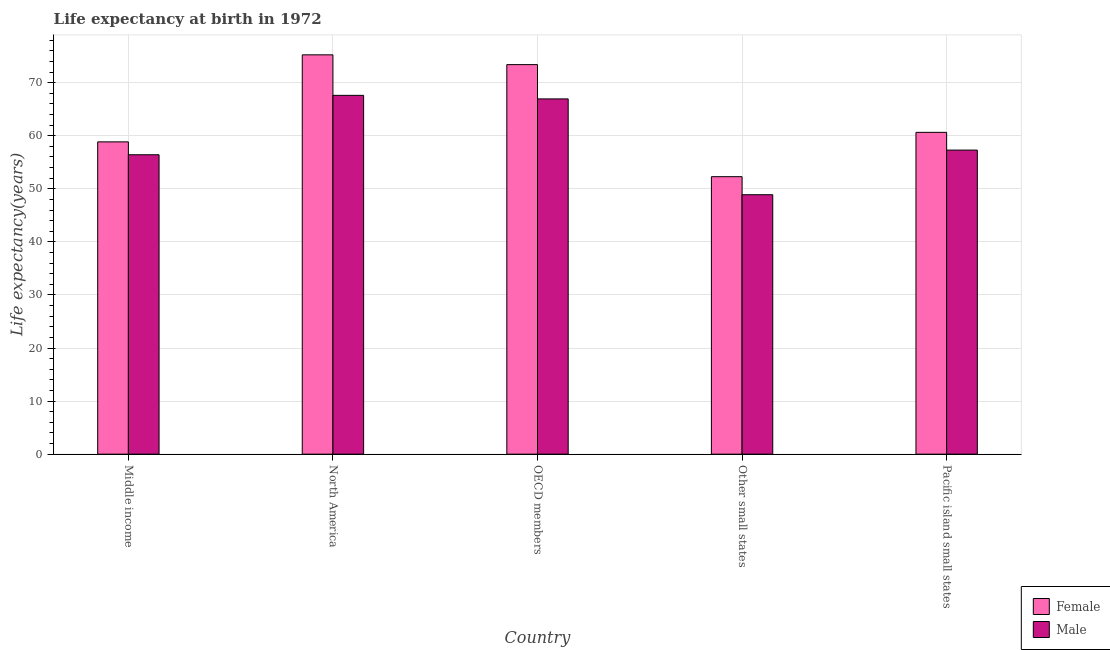How many groups of bars are there?
Keep it short and to the point. 5. Are the number of bars on each tick of the X-axis equal?
Ensure brevity in your answer.  Yes. How many bars are there on the 3rd tick from the left?
Give a very brief answer. 2. How many bars are there on the 5th tick from the right?
Your answer should be very brief. 2. What is the label of the 4th group of bars from the left?
Provide a succinct answer. Other small states. What is the life expectancy(male) in Middle income?
Your response must be concise. 56.41. Across all countries, what is the maximum life expectancy(male)?
Your response must be concise. 67.6. Across all countries, what is the minimum life expectancy(female)?
Your response must be concise. 52.28. In which country was the life expectancy(female) maximum?
Give a very brief answer. North America. In which country was the life expectancy(female) minimum?
Give a very brief answer. Other small states. What is the total life expectancy(female) in the graph?
Your answer should be compact. 320.38. What is the difference between the life expectancy(male) in North America and that in OECD members?
Ensure brevity in your answer.  0.67. What is the difference between the life expectancy(female) in Pacific island small states and the life expectancy(male) in Other small states?
Offer a terse response. 11.75. What is the average life expectancy(male) per country?
Your answer should be very brief. 59.42. What is the difference between the life expectancy(male) and life expectancy(female) in Middle income?
Provide a short and direct response. -2.43. In how many countries, is the life expectancy(female) greater than 4 years?
Offer a terse response. 5. What is the ratio of the life expectancy(female) in North America to that in Other small states?
Offer a terse response. 1.44. Is the difference between the life expectancy(male) in Middle income and North America greater than the difference between the life expectancy(female) in Middle income and North America?
Provide a short and direct response. Yes. What is the difference between the highest and the second highest life expectancy(male)?
Your answer should be compact. 0.67. What is the difference between the highest and the lowest life expectancy(male)?
Offer a terse response. 18.72. Is the sum of the life expectancy(male) in Middle income and North America greater than the maximum life expectancy(female) across all countries?
Offer a terse response. Yes. What does the 1st bar from the left in Middle income represents?
Offer a terse response. Female. What does the 1st bar from the right in Other small states represents?
Your answer should be compact. Male. How many bars are there?
Offer a very short reply. 10. Are all the bars in the graph horizontal?
Your answer should be compact. No. How many countries are there in the graph?
Provide a succinct answer. 5. Are the values on the major ticks of Y-axis written in scientific E-notation?
Provide a succinct answer. No. Does the graph contain grids?
Your answer should be compact. Yes. Where does the legend appear in the graph?
Give a very brief answer. Bottom right. What is the title of the graph?
Provide a short and direct response. Life expectancy at birth in 1972. What is the label or title of the X-axis?
Your answer should be very brief. Country. What is the label or title of the Y-axis?
Offer a very short reply. Life expectancy(years). What is the Life expectancy(years) of Female in Middle income?
Keep it short and to the point. 58.84. What is the Life expectancy(years) in Male in Middle income?
Ensure brevity in your answer.  56.41. What is the Life expectancy(years) in Female in North America?
Your answer should be very brief. 75.24. What is the Life expectancy(years) in Male in North America?
Ensure brevity in your answer.  67.6. What is the Life expectancy(years) of Female in OECD members?
Your response must be concise. 73.39. What is the Life expectancy(years) in Male in OECD members?
Give a very brief answer. 66.93. What is the Life expectancy(years) in Female in Other small states?
Offer a terse response. 52.28. What is the Life expectancy(years) in Male in Other small states?
Offer a very short reply. 48.88. What is the Life expectancy(years) in Female in Pacific island small states?
Your response must be concise. 60.63. What is the Life expectancy(years) of Male in Pacific island small states?
Provide a succinct answer. 57.29. Across all countries, what is the maximum Life expectancy(years) in Female?
Provide a succinct answer. 75.24. Across all countries, what is the maximum Life expectancy(years) of Male?
Provide a short and direct response. 67.6. Across all countries, what is the minimum Life expectancy(years) in Female?
Your response must be concise. 52.28. Across all countries, what is the minimum Life expectancy(years) of Male?
Offer a terse response. 48.88. What is the total Life expectancy(years) of Female in the graph?
Make the answer very short. 320.38. What is the total Life expectancy(years) of Male in the graph?
Ensure brevity in your answer.  297.12. What is the difference between the Life expectancy(years) of Female in Middle income and that in North America?
Your response must be concise. -16.4. What is the difference between the Life expectancy(years) of Male in Middle income and that in North America?
Give a very brief answer. -11.19. What is the difference between the Life expectancy(years) in Female in Middle income and that in OECD members?
Ensure brevity in your answer.  -14.55. What is the difference between the Life expectancy(years) in Male in Middle income and that in OECD members?
Ensure brevity in your answer.  -10.52. What is the difference between the Life expectancy(years) of Female in Middle income and that in Other small states?
Offer a terse response. 6.56. What is the difference between the Life expectancy(years) of Male in Middle income and that in Other small states?
Offer a terse response. 7.53. What is the difference between the Life expectancy(years) in Female in Middle income and that in Pacific island small states?
Your answer should be compact. -1.79. What is the difference between the Life expectancy(years) of Male in Middle income and that in Pacific island small states?
Provide a succinct answer. -0.88. What is the difference between the Life expectancy(years) of Female in North America and that in OECD members?
Ensure brevity in your answer.  1.84. What is the difference between the Life expectancy(years) in Male in North America and that in OECD members?
Ensure brevity in your answer.  0.67. What is the difference between the Life expectancy(years) of Female in North America and that in Other small states?
Offer a terse response. 22.95. What is the difference between the Life expectancy(years) in Male in North America and that in Other small states?
Make the answer very short. 18.72. What is the difference between the Life expectancy(years) in Female in North America and that in Pacific island small states?
Give a very brief answer. 14.6. What is the difference between the Life expectancy(years) in Male in North America and that in Pacific island small states?
Offer a very short reply. 10.31. What is the difference between the Life expectancy(years) in Female in OECD members and that in Other small states?
Ensure brevity in your answer.  21.11. What is the difference between the Life expectancy(years) in Male in OECD members and that in Other small states?
Offer a very short reply. 18.05. What is the difference between the Life expectancy(years) in Female in OECD members and that in Pacific island small states?
Provide a succinct answer. 12.76. What is the difference between the Life expectancy(years) of Male in OECD members and that in Pacific island small states?
Your answer should be very brief. 9.65. What is the difference between the Life expectancy(years) in Female in Other small states and that in Pacific island small states?
Offer a terse response. -8.35. What is the difference between the Life expectancy(years) of Male in Other small states and that in Pacific island small states?
Offer a terse response. -8.41. What is the difference between the Life expectancy(years) of Female in Middle income and the Life expectancy(years) of Male in North America?
Give a very brief answer. -8.76. What is the difference between the Life expectancy(years) in Female in Middle income and the Life expectancy(years) in Male in OECD members?
Your response must be concise. -8.1. What is the difference between the Life expectancy(years) of Female in Middle income and the Life expectancy(years) of Male in Other small states?
Offer a very short reply. 9.96. What is the difference between the Life expectancy(years) of Female in Middle income and the Life expectancy(years) of Male in Pacific island small states?
Provide a short and direct response. 1.55. What is the difference between the Life expectancy(years) of Female in North America and the Life expectancy(years) of Male in OECD members?
Provide a succinct answer. 8.3. What is the difference between the Life expectancy(years) in Female in North America and the Life expectancy(years) in Male in Other small states?
Your answer should be compact. 26.35. What is the difference between the Life expectancy(years) of Female in North America and the Life expectancy(years) of Male in Pacific island small states?
Offer a terse response. 17.95. What is the difference between the Life expectancy(years) in Female in OECD members and the Life expectancy(years) in Male in Other small states?
Give a very brief answer. 24.51. What is the difference between the Life expectancy(years) in Female in OECD members and the Life expectancy(years) in Male in Pacific island small states?
Provide a succinct answer. 16.1. What is the difference between the Life expectancy(years) of Female in Other small states and the Life expectancy(years) of Male in Pacific island small states?
Provide a short and direct response. -5.01. What is the average Life expectancy(years) in Female per country?
Your answer should be compact. 64.08. What is the average Life expectancy(years) of Male per country?
Keep it short and to the point. 59.42. What is the difference between the Life expectancy(years) in Female and Life expectancy(years) in Male in Middle income?
Your answer should be very brief. 2.43. What is the difference between the Life expectancy(years) of Female and Life expectancy(years) of Male in North America?
Ensure brevity in your answer.  7.63. What is the difference between the Life expectancy(years) of Female and Life expectancy(years) of Male in OECD members?
Ensure brevity in your answer.  6.46. What is the difference between the Life expectancy(years) in Female and Life expectancy(years) in Male in Other small states?
Provide a short and direct response. 3.4. What is the difference between the Life expectancy(years) of Female and Life expectancy(years) of Male in Pacific island small states?
Offer a very short reply. 3.34. What is the ratio of the Life expectancy(years) in Female in Middle income to that in North America?
Your answer should be very brief. 0.78. What is the ratio of the Life expectancy(years) of Male in Middle income to that in North America?
Your answer should be very brief. 0.83. What is the ratio of the Life expectancy(years) in Female in Middle income to that in OECD members?
Your response must be concise. 0.8. What is the ratio of the Life expectancy(years) in Male in Middle income to that in OECD members?
Offer a terse response. 0.84. What is the ratio of the Life expectancy(years) in Female in Middle income to that in Other small states?
Provide a succinct answer. 1.13. What is the ratio of the Life expectancy(years) of Male in Middle income to that in Other small states?
Your response must be concise. 1.15. What is the ratio of the Life expectancy(years) of Female in Middle income to that in Pacific island small states?
Your response must be concise. 0.97. What is the ratio of the Life expectancy(years) of Male in Middle income to that in Pacific island small states?
Offer a terse response. 0.98. What is the ratio of the Life expectancy(years) of Female in North America to that in OECD members?
Ensure brevity in your answer.  1.03. What is the ratio of the Life expectancy(years) in Male in North America to that in OECD members?
Offer a terse response. 1.01. What is the ratio of the Life expectancy(years) in Female in North America to that in Other small states?
Make the answer very short. 1.44. What is the ratio of the Life expectancy(years) in Male in North America to that in Other small states?
Offer a terse response. 1.38. What is the ratio of the Life expectancy(years) in Female in North America to that in Pacific island small states?
Your answer should be very brief. 1.24. What is the ratio of the Life expectancy(years) in Male in North America to that in Pacific island small states?
Your response must be concise. 1.18. What is the ratio of the Life expectancy(years) of Female in OECD members to that in Other small states?
Offer a terse response. 1.4. What is the ratio of the Life expectancy(years) in Male in OECD members to that in Other small states?
Your response must be concise. 1.37. What is the ratio of the Life expectancy(years) in Female in OECD members to that in Pacific island small states?
Keep it short and to the point. 1.21. What is the ratio of the Life expectancy(years) of Male in OECD members to that in Pacific island small states?
Offer a very short reply. 1.17. What is the ratio of the Life expectancy(years) in Female in Other small states to that in Pacific island small states?
Give a very brief answer. 0.86. What is the ratio of the Life expectancy(years) in Male in Other small states to that in Pacific island small states?
Provide a succinct answer. 0.85. What is the difference between the highest and the second highest Life expectancy(years) of Female?
Provide a short and direct response. 1.84. What is the difference between the highest and the second highest Life expectancy(years) in Male?
Offer a very short reply. 0.67. What is the difference between the highest and the lowest Life expectancy(years) of Female?
Give a very brief answer. 22.95. What is the difference between the highest and the lowest Life expectancy(years) in Male?
Your response must be concise. 18.72. 